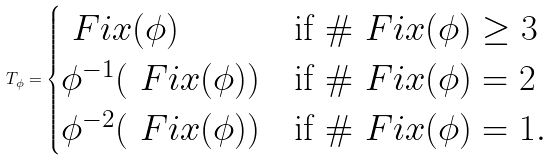<formula> <loc_0><loc_0><loc_500><loc_500>T _ { \phi } = \begin{cases} \ F i x ( \phi ) & \text {if } \# \ F i x ( \phi ) \geq 3 \\ \phi ^ { - 1 } ( \ F i x ( \phi ) ) & \text {if } \# \ F i x ( \phi ) = 2 \\ \phi ^ { - 2 } ( \ F i x ( \phi ) ) & \text {if } \# \ F i x ( \phi ) = 1 . \end{cases}</formula> 